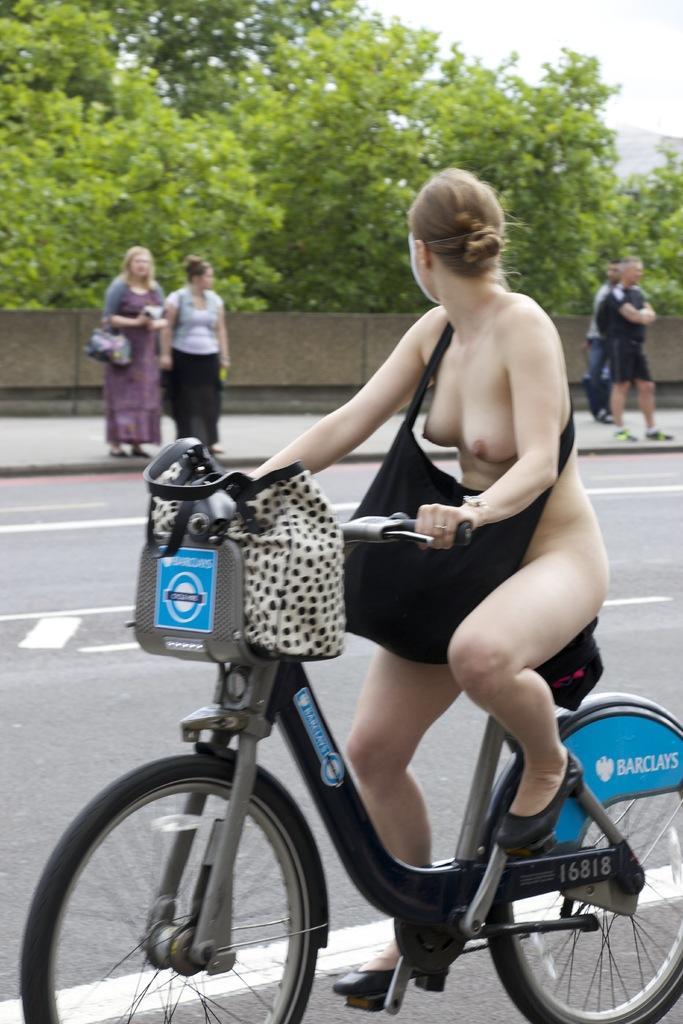Can you describe this image briefly? In this image the woman is riding a bicycle on the road and wearing a handbag. At the back side there is a tree,on the footpath there are people standing. 